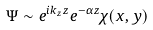Convert formula to latex. <formula><loc_0><loc_0><loc_500><loc_500>\Psi \sim e ^ { i k _ { z } z } e ^ { - \alpha z } \chi ( x , y )</formula> 